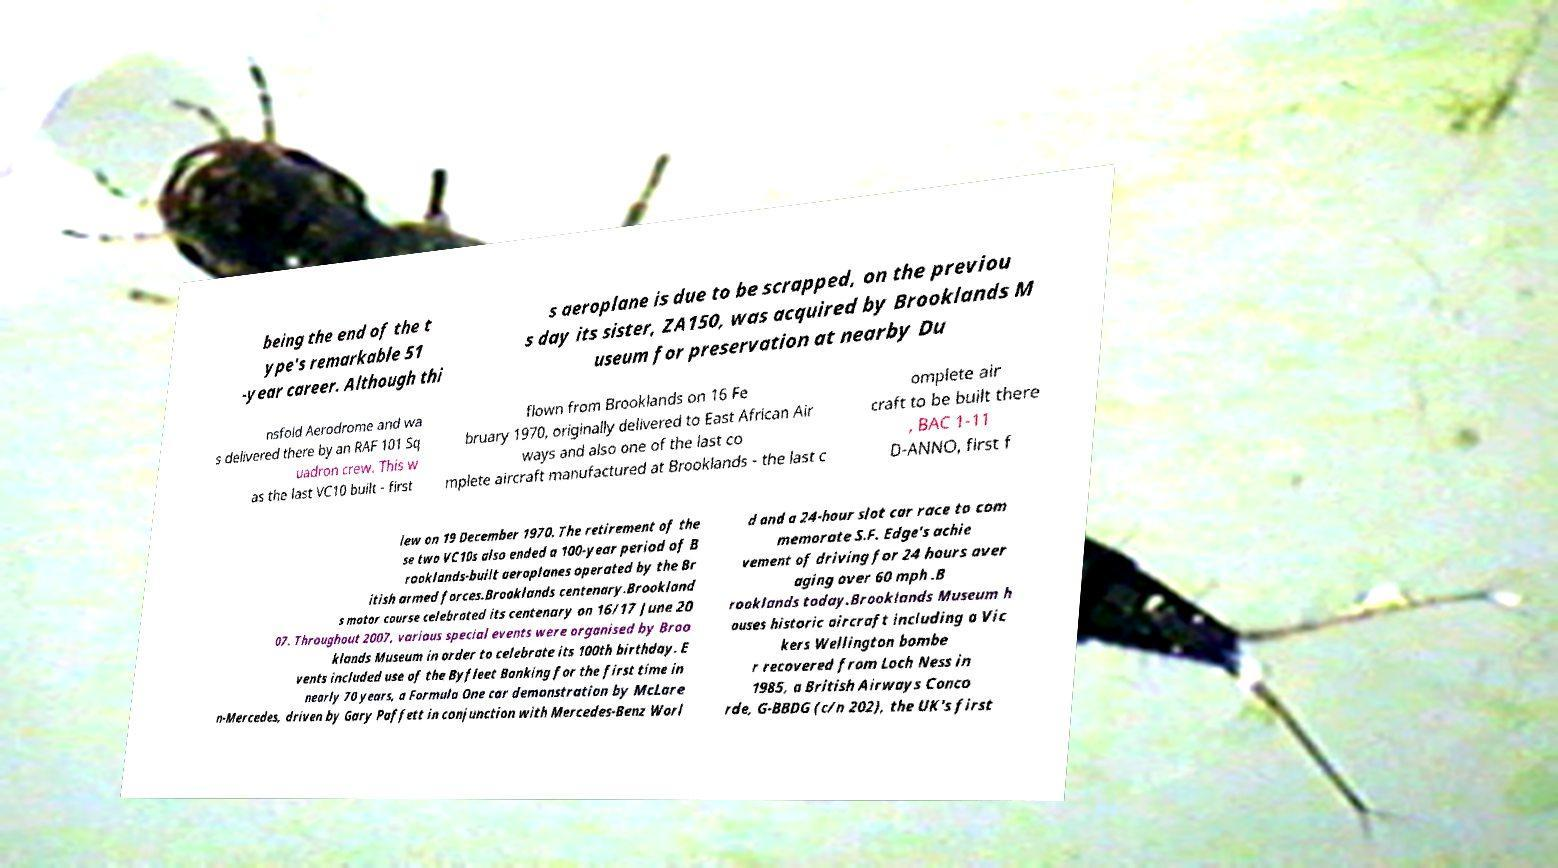There's text embedded in this image that I need extracted. Can you transcribe it verbatim? being the end of the t ype's remarkable 51 -year career. Although thi s aeroplane is due to be scrapped, on the previou s day its sister, ZA150, was acquired by Brooklands M useum for preservation at nearby Du nsfold Aerodrome and wa s delivered there by an RAF 101 Sq uadron crew. This w as the last VC10 built - first flown from Brooklands on 16 Fe bruary 1970, originally delivered to East African Air ways and also one of the last co mplete aircraft manufactured at Brooklands - the last c omplete air craft to be built there , BAC 1-11 D-ANNO, first f lew on 19 December 1970. The retirement of the se two VC10s also ended a 100-year period of B rooklands-built aeroplanes operated by the Br itish armed forces.Brooklands centenary.Brookland s motor course celebrated its centenary on 16/17 June 20 07. Throughout 2007, various special events were organised by Broo klands Museum in order to celebrate its 100th birthday. E vents included use of the Byfleet Banking for the first time in nearly 70 years, a Formula One car demonstration by McLare n-Mercedes, driven by Gary Paffett in conjunction with Mercedes-Benz Worl d and a 24-hour slot car race to com memorate S.F. Edge's achie vement of driving for 24 hours aver aging over 60 mph .B rooklands today.Brooklands Museum h ouses historic aircraft including a Vic kers Wellington bombe r recovered from Loch Ness in 1985, a British Airways Conco rde, G-BBDG (c/n 202), the UK's first 